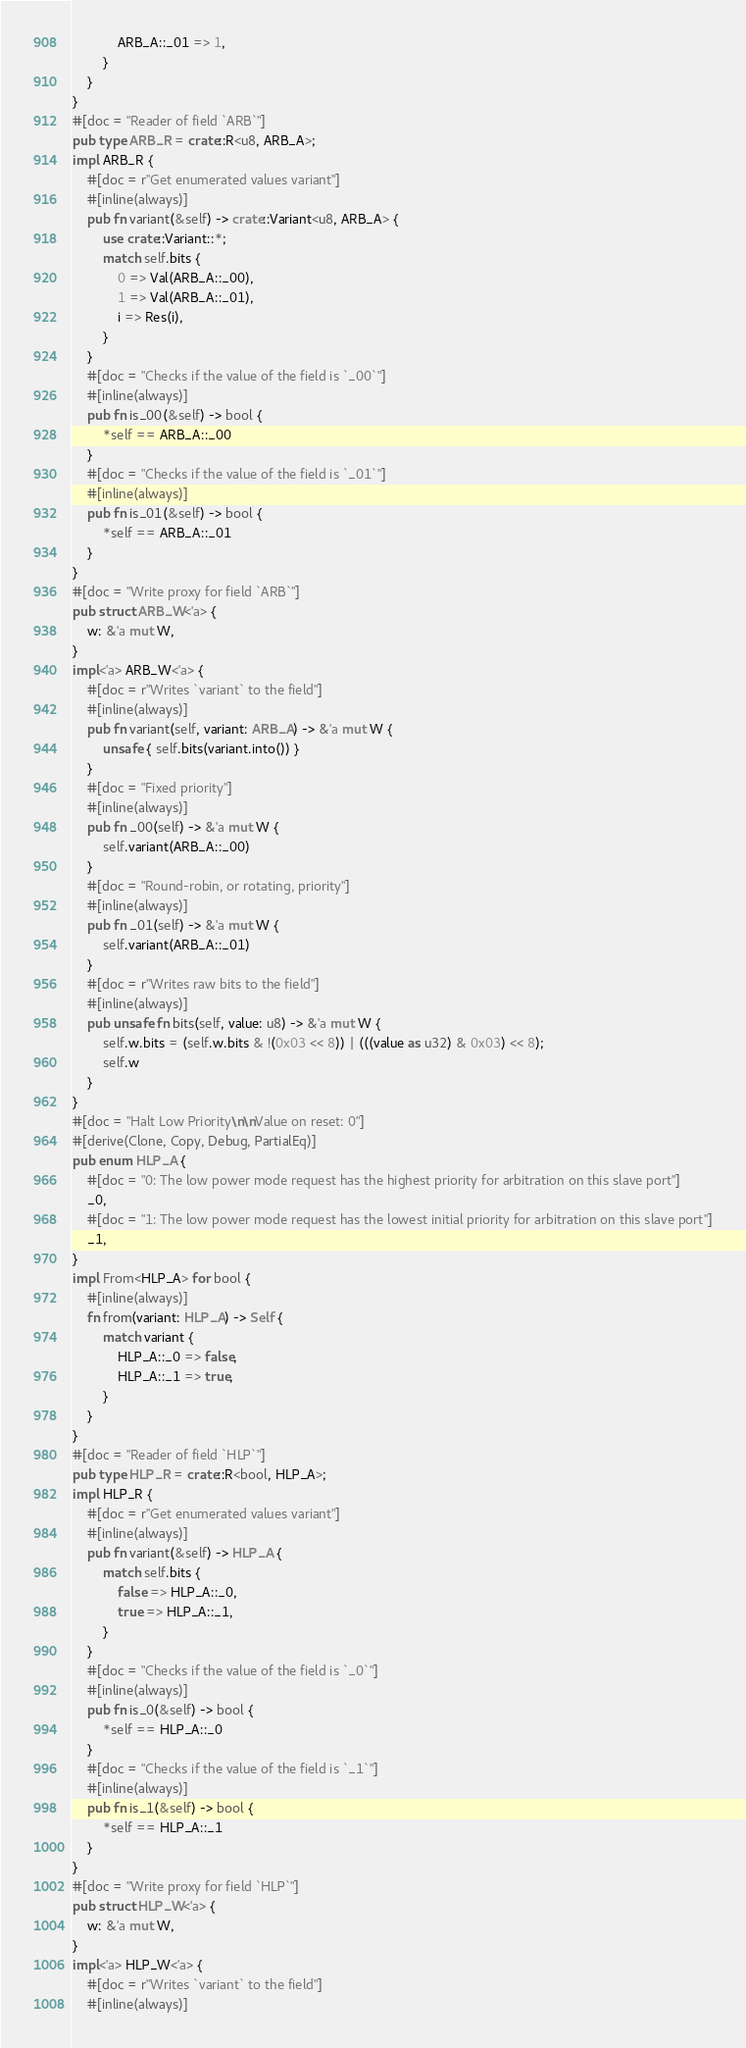Convert code to text. <code><loc_0><loc_0><loc_500><loc_500><_Rust_>            ARB_A::_01 => 1,
        }
    }
}
#[doc = "Reader of field `ARB`"]
pub type ARB_R = crate::R<u8, ARB_A>;
impl ARB_R {
    #[doc = r"Get enumerated values variant"]
    #[inline(always)]
    pub fn variant(&self) -> crate::Variant<u8, ARB_A> {
        use crate::Variant::*;
        match self.bits {
            0 => Val(ARB_A::_00),
            1 => Val(ARB_A::_01),
            i => Res(i),
        }
    }
    #[doc = "Checks if the value of the field is `_00`"]
    #[inline(always)]
    pub fn is_00(&self) -> bool {
        *self == ARB_A::_00
    }
    #[doc = "Checks if the value of the field is `_01`"]
    #[inline(always)]
    pub fn is_01(&self) -> bool {
        *self == ARB_A::_01
    }
}
#[doc = "Write proxy for field `ARB`"]
pub struct ARB_W<'a> {
    w: &'a mut W,
}
impl<'a> ARB_W<'a> {
    #[doc = r"Writes `variant` to the field"]
    #[inline(always)]
    pub fn variant(self, variant: ARB_A) -> &'a mut W {
        unsafe { self.bits(variant.into()) }
    }
    #[doc = "Fixed priority"]
    #[inline(always)]
    pub fn _00(self) -> &'a mut W {
        self.variant(ARB_A::_00)
    }
    #[doc = "Round-robin, or rotating, priority"]
    #[inline(always)]
    pub fn _01(self) -> &'a mut W {
        self.variant(ARB_A::_01)
    }
    #[doc = r"Writes raw bits to the field"]
    #[inline(always)]
    pub unsafe fn bits(self, value: u8) -> &'a mut W {
        self.w.bits = (self.w.bits & !(0x03 << 8)) | (((value as u32) & 0x03) << 8);
        self.w
    }
}
#[doc = "Halt Low Priority\n\nValue on reset: 0"]
#[derive(Clone, Copy, Debug, PartialEq)]
pub enum HLP_A {
    #[doc = "0: The low power mode request has the highest priority for arbitration on this slave port"]
    _0,
    #[doc = "1: The low power mode request has the lowest initial priority for arbitration on this slave port"]
    _1,
}
impl From<HLP_A> for bool {
    #[inline(always)]
    fn from(variant: HLP_A) -> Self {
        match variant {
            HLP_A::_0 => false,
            HLP_A::_1 => true,
        }
    }
}
#[doc = "Reader of field `HLP`"]
pub type HLP_R = crate::R<bool, HLP_A>;
impl HLP_R {
    #[doc = r"Get enumerated values variant"]
    #[inline(always)]
    pub fn variant(&self) -> HLP_A {
        match self.bits {
            false => HLP_A::_0,
            true => HLP_A::_1,
        }
    }
    #[doc = "Checks if the value of the field is `_0`"]
    #[inline(always)]
    pub fn is_0(&self) -> bool {
        *self == HLP_A::_0
    }
    #[doc = "Checks if the value of the field is `_1`"]
    #[inline(always)]
    pub fn is_1(&self) -> bool {
        *self == HLP_A::_1
    }
}
#[doc = "Write proxy for field `HLP`"]
pub struct HLP_W<'a> {
    w: &'a mut W,
}
impl<'a> HLP_W<'a> {
    #[doc = r"Writes `variant` to the field"]
    #[inline(always)]</code> 